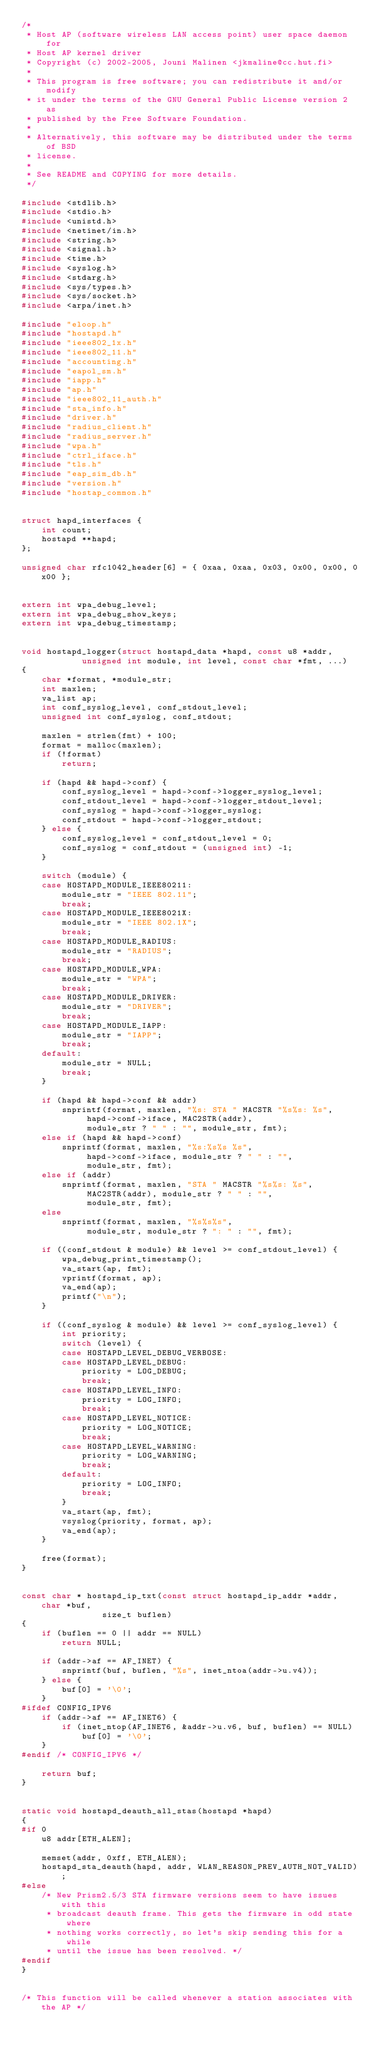Convert code to text. <code><loc_0><loc_0><loc_500><loc_500><_C_>/*
 * Host AP (software wireless LAN access point) user space daemon for
 * Host AP kernel driver
 * Copyright (c) 2002-2005, Jouni Malinen <jkmaline@cc.hut.fi>
 *
 * This program is free software; you can redistribute it and/or modify
 * it under the terms of the GNU General Public License version 2 as
 * published by the Free Software Foundation.
 *
 * Alternatively, this software may be distributed under the terms of BSD
 * license.
 *
 * See README and COPYING for more details.
 */

#include <stdlib.h>
#include <stdio.h>
#include <unistd.h>
#include <netinet/in.h>
#include <string.h>
#include <signal.h>
#include <time.h>
#include <syslog.h>
#include <stdarg.h>
#include <sys/types.h>
#include <sys/socket.h>
#include <arpa/inet.h>

#include "eloop.h"
#include "hostapd.h"
#include "ieee802_1x.h"
#include "ieee802_11.h"
#include "accounting.h"
#include "eapol_sm.h"
#include "iapp.h"
#include "ap.h"
#include "ieee802_11_auth.h"
#include "sta_info.h"
#include "driver.h"
#include "radius_client.h"
#include "radius_server.h"
#include "wpa.h"
#include "ctrl_iface.h"
#include "tls.h"
#include "eap_sim_db.h"
#include "version.h"
#include "hostap_common.h"


struct hapd_interfaces {
	int count;
	hostapd **hapd;
};

unsigned char rfc1042_header[6] = { 0xaa, 0xaa, 0x03, 0x00, 0x00, 0x00 };


extern int wpa_debug_level;
extern int wpa_debug_show_keys;
extern int wpa_debug_timestamp;


void hostapd_logger(struct hostapd_data *hapd, const u8 *addr,
		    unsigned int module, int level, const char *fmt, ...)
{
	char *format, *module_str;
	int maxlen;
	va_list ap;
	int conf_syslog_level, conf_stdout_level;
	unsigned int conf_syslog, conf_stdout;

	maxlen = strlen(fmt) + 100;
	format = malloc(maxlen);
	if (!format)
		return;

	if (hapd && hapd->conf) {
		conf_syslog_level = hapd->conf->logger_syslog_level;
		conf_stdout_level = hapd->conf->logger_stdout_level;
		conf_syslog = hapd->conf->logger_syslog;
		conf_stdout = hapd->conf->logger_stdout;
	} else {
		conf_syslog_level = conf_stdout_level = 0;
		conf_syslog = conf_stdout = (unsigned int) -1;
	}

	switch (module) {
	case HOSTAPD_MODULE_IEEE80211:
		module_str = "IEEE 802.11";
		break;
	case HOSTAPD_MODULE_IEEE8021X:
		module_str = "IEEE 802.1X";
		break;
	case HOSTAPD_MODULE_RADIUS:
		module_str = "RADIUS";
		break;
	case HOSTAPD_MODULE_WPA:
		module_str = "WPA";
		break;
	case HOSTAPD_MODULE_DRIVER:
		module_str = "DRIVER";
		break;
	case HOSTAPD_MODULE_IAPP:
		module_str = "IAPP";
		break;
	default:
		module_str = NULL;
		break;
	}

	if (hapd && hapd->conf && addr)
		snprintf(format, maxlen, "%s: STA " MACSTR "%s%s: %s",
			 hapd->conf->iface, MAC2STR(addr),
			 module_str ? " " : "", module_str, fmt);
	else if (hapd && hapd->conf)
		snprintf(format, maxlen, "%s:%s%s %s",
			 hapd->conf->iface, module_str ? " " : "",
			 module_str, fmt);
	else if (addr)
		snprintf(format, maxlen, "STA " MACSTR "%s%s: %s",
			 MAC2STR(addr), module_str ? " " : "",
			 module_str, fmt);
	else
		snprintf(format, maxlen, "%s%s%s",
			 module_str, module_str ? ": " : "", fmt);

	if ((conf_stdout & module) && level >= conf_stdout_level) {
		wpa_debug_print_timestamp();
		va_start(ap, fmt);
		vprintf(format, ap);
		va_end(ap);
		printf("\n");
	}

	if ((conf_syslog & module) && level >= conf_syslog_level) {
		int priority;
		switch (level) {
		case HOSTAPD_LEVEL_DEBUG_VERBOSE:
		case HOSTAPD_LEVEL_DEBUG:
			priority = LOG_DEBUG;
			break;
		case HOSTAPD_LEVEL_INFO:
			priority = LOG_INFO;
			break;
		case HOSTAPD_LEVEL_NOTICE:
			priority = LOG_NOTICE;
			break;
		case HOSTAPD_LEVEL_WARNING:
			priority = LOG_WARNING;
			break;
		default:
			priority = LOG_INFO;
			break;
		}
		va_start(ap, fmt);
		vsyslog(priority, format, ap);
		va_end(ap);
	}

	free(format);
}


const char * hostapd_ip_txt(const struct hostapd_ip_addr *addr, char *buf,
			    size_t buflen)
{
	if (buflen == 0 || addr == NULL)
		return NULL;

	if (addr->af == AF_INET) {
		snprintf(buf, buflen, "%s", inet_ntoa(addr->u.v4));
	} else {
		buf[0] = '\0';
	}
#ifdef CONFIG_IPV6
	if (addr->af == AF_INET6) {
		if (inet_ntop(AF_INET6, &addr->u.v6, buf, buflen) == NULL)
			buf[0] = '\0';
	}
#endif /* CONFIG_IPV6 */

	return buf;
}


static void hostapd_deauth_all_stas(hostapd *hapd)
{
#if 0
	u8 addr[ETH_ALEN];

	memset(addr, 0xff, ETH_ALEN);
	hostapd_sta_deauth(hapd, addr, WLAN_REASON_PREV_AUTH_NOT_VALID);
#else
	/* New Prism2.5/3 STA firmware versions seem to have issues with this
	 * broadcast deauth frame. This gets the firmware in odd state where
	 * nothing works correctly, so let's skip sending this for a while
	 * until the issue has been resolved. */
#endif
}


/* This function will be called whenever a station associates with the AP */</code> 